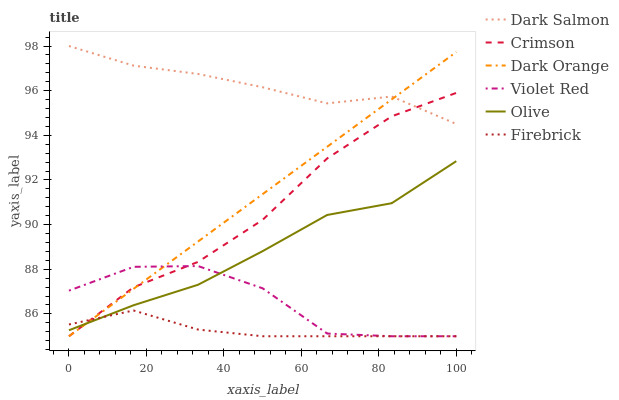Does Firebrick have the minimum area under the curve?
Answer yes or no. Yes. Does Dark Salmon have the maximum area under the curve?
Answer yes or no. Yes. Does Violet Red have the minimum area under the curve?
Answer yes or no. No. Does Violet Red have the maximum area under the curve?
Answer yes or no. No. Is Dark Orange the smoothest?
Answer yes or no. Yes. Is Violet Red the roughest?
Answer yes or no. Yes. Is Firebrick the smoothest?
Answer yes or no. No. Is Firebrick the roughest?
Answer yes or no. No. Does Dark Salmon have the lowest value?
Answer yes or no. No. Does Dark Salmon have the highest value?
Answer yes or no. Yes. Does Violet Red have the highest value?
Answer yes or no. No. Is Olive less than Dark Salmon?
Answer yes or no. Yes. Is Dark Salmon greater than Olive?
Answer yes or no. Yes. Does Olive intersect Violet Red?
Answer yes or no. Yes. Is Olive less than Violet Red?
Answer yes or no. No. Is Olive greater than Violet Red?
Answer yes or no. No. Does Olive intersect Dark Salmon?
Answer yes or no. No. 